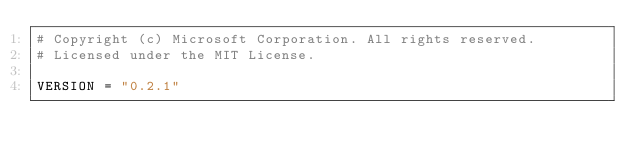Convert code to text. <code><loc_0><loc_0><loc_500><loc_500><_Python_># Copyright (c) Microsoft Corporation. All rights reserved.
# Licensed under the MIT License.

VERSION = "0.2.1"
</code> 